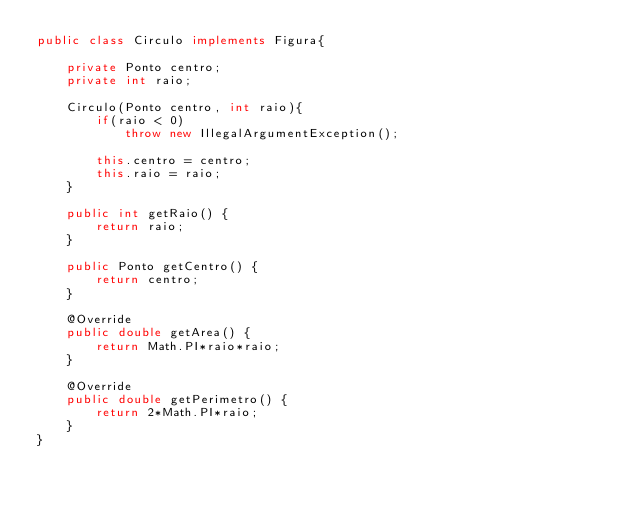Convert code to text. <code><loc_0><loc_0><loc_500><loc_500><_Java_>public class Circulo implements Figura{

    private Ponto centro;
    private int raio;

    Circulo(Ponto centro, int raio){
        if(raio < 0)
            throw new IllegalArgumentException();

        this.centro = centro;
        this.raio = raio;
    }

    public int getRaio() {
        return raio;
    }

    public Ponto getCentro() {
        return centro;
    }

    @Override
    public double getArea() {
        return Math.PI*raio*raio;
    }

    @Override
    public double getPerimetro() {
        return 2*Math.PI*raio;
    }
}
</code> 